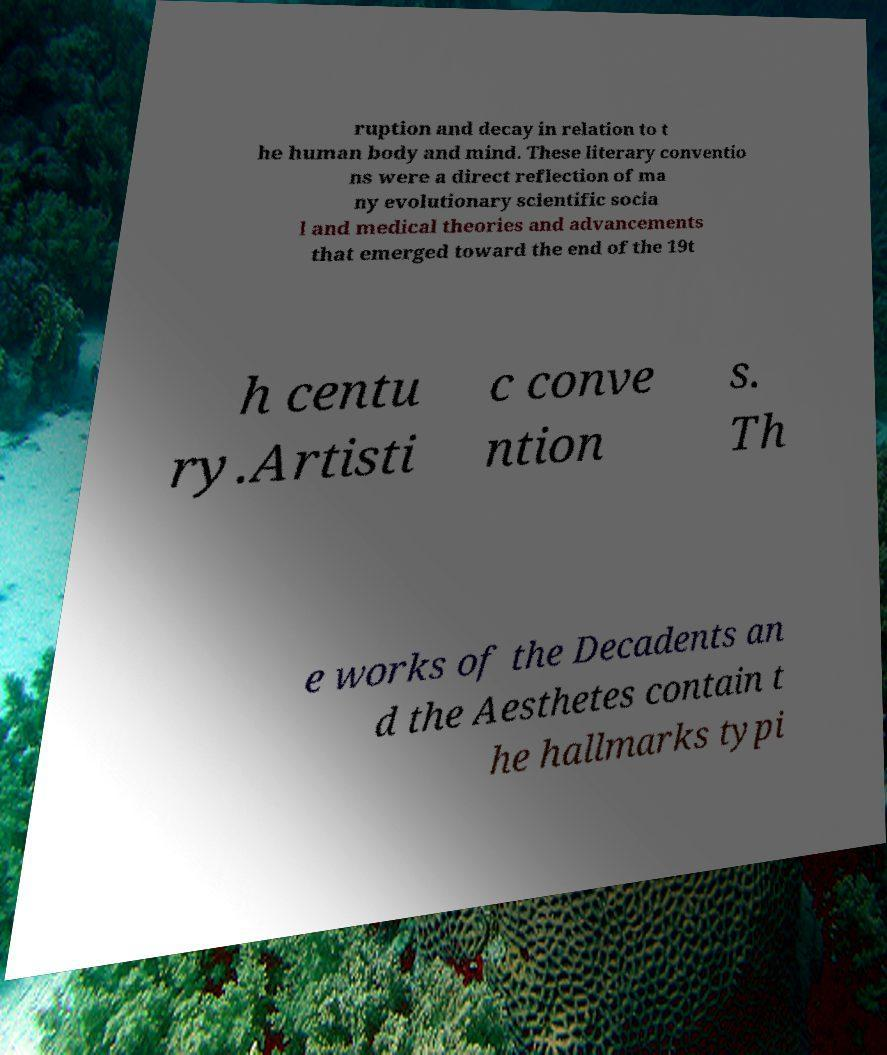Please identify and transcribe the text found in this image. ruption and decay in relation to t he human body and mind. These literary conventio ns were a direct reflection of ma ny evolutionary scientific socia l and medical theories and advancements that emerged toward the end of the 19t h centu ry.Artisti c conve ntion s. Th e works of the Decadents an d the Aesthetes contain t he hallmarks typi 